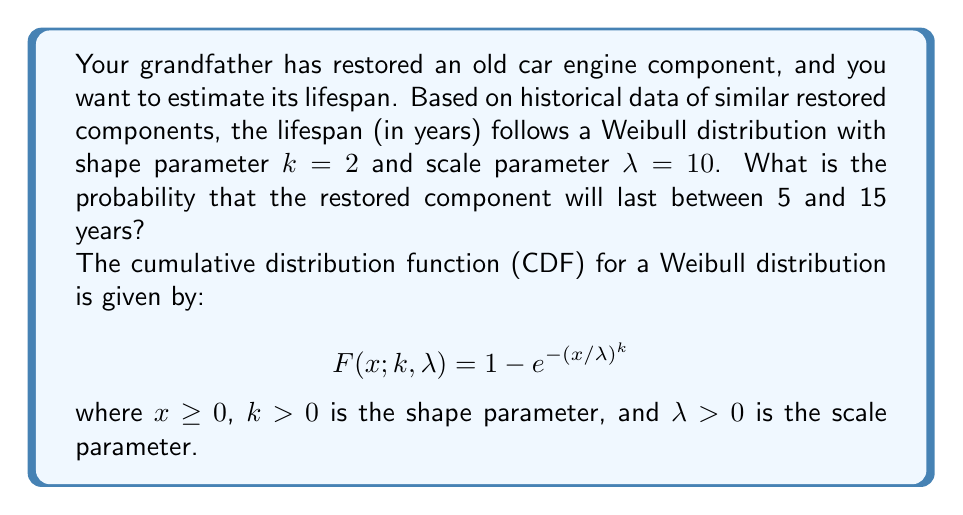Show me your answer to this math problem. To solve this problem, we need to use the cumulative distribution function (CDF) of the Weibull distribution. We'll follow these steps:

1. Calculate the probability that the component lasts less than or equal to 15 years.
2. Calculate the probability that the component lasts less than or equal to 5 years.
3. Subtract the result from step 2 from the result of step 1 to get the probability of lasting between 5 and 15 years.

Step 1: Probability of lasting less than or equal to 15 years
$$ P(X \leq 15) = F(15; 2, 10) = 1 - e^{-(15/10)^2} $$
$$ = 1 - e^{-2.25} \approx 0.8946 $$

Step 2: Probability of lasting less than or equal to 5 years
$$ P(X \leq 5) = F(5; 2, 10) = 1 - e^{-(5/10)^2} $$
$$ = 1 - e^{-0.25} \approx 0.2212 $$

Step 3: Probability of lasting between 5 and 15 years
$$ P(5 < X \leq 15) = P(X \leq 15) - P(X \leq 5) $$
$$ = 0.8946 - 0.2212 = 0.6734 $$

Therefore, the probability that the restored component will last between 5 and 15 years is approximately 0.6734 or 67.34%.
Answer: The probability that the restored component will last between 5 and 15 years is approximately 0.6734 or 67.34%. 